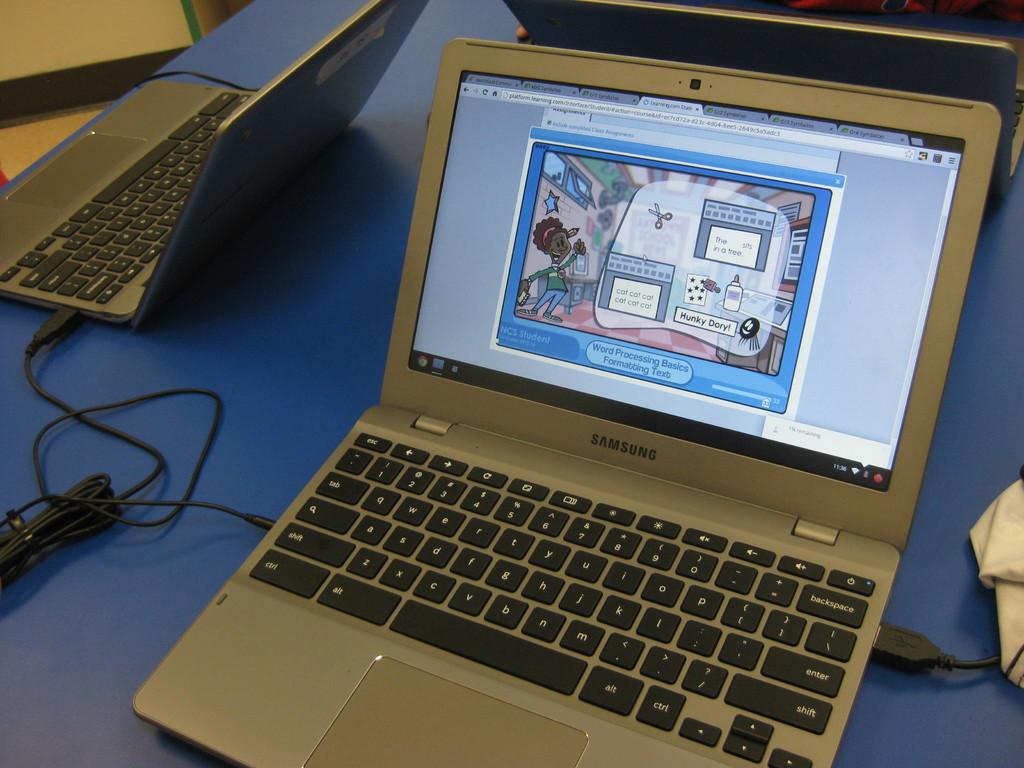What is the brand of the laptop?
Your answer should be very brief. Samsung. What text is visible on the screen?
Your answer should be very brief. Word processing basics formatting text. 